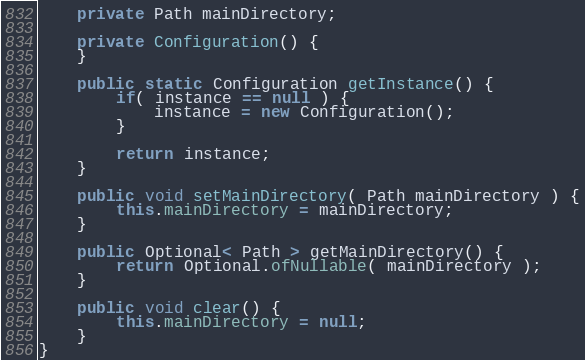Convert code to text. <code><loc_0><loc_0><loc_500><loc_500><_Java_>    private Path mainDirectory;

    private Configuration() {
    }

    public static Configuration getInstance() {
        if( instance == null ) {
            instance = new Configuration();
        }

        return instance;
    }

    public void setMainDirectory( Path mainDirectory ) {
        this.mainDirectory = mainDirectory;
    }

    public Optional< Path > getMainDirectory() {
        return Optional.ofNullable( mainDirectory );
    }

    public void clear() {
        this.mainDirectory = null;
    }
}
</code> 